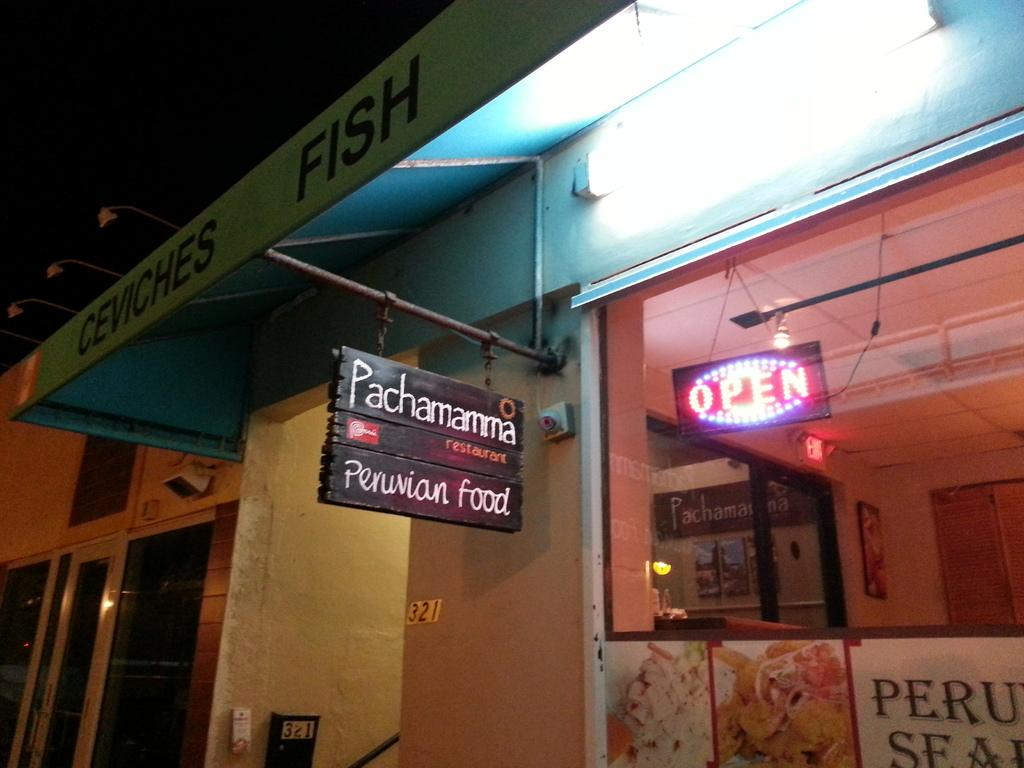<image>
Create a compact narrative representing the image presented. a sign for Pachama Peruvian food reads OPEN 